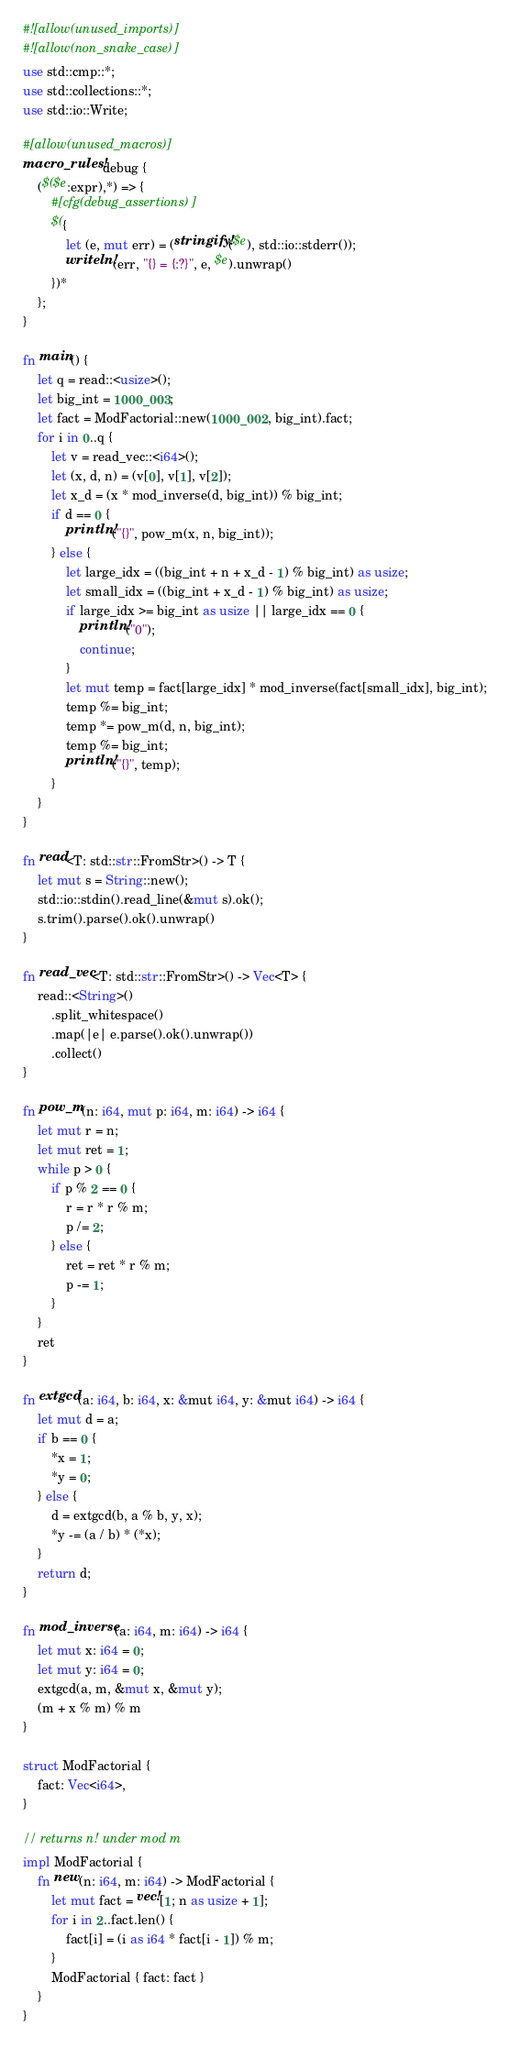<code> <loc_0><loc_0><loc_500><loc_500><_Rust_>#![allow(unused_imports)]
#![allow(non_snake_case)]
use std::cmp::*;
use std::collections::*;
use std::io::Write;

#[allow(unused_macros)]
macro_rules! debug {
    ($($e:expr),*) => {
        #[cfg(debug_assertions)]
        $({
            let (e, mut err) = (stringify!($e), std::io::stderr());
            writeln!(err, "{} = {:?}", e, $e).unwrap()
        })*
    };
}

fn main() {
    let q = read::<usize>();
    let big_int = 1000_003;
    let fact = ModFactorial::new(1000_002, big_int).fact;
    for i in 0..q {
        let v = read_vec::<i64>();
        let (x, d, n) = (v[0], v[1], v[2]);
        let x_d = (x * mod_inverse(d, big_int)) % big_int;
        if d == 0 {
            println!("{}", pow_m(x, n, big_int));
        } else {
            let large_idx = ((big_int + n + x_d - 1) % big_int) as usize;
            let small_idx = ((big_int + x_d - 1) % big_int) as usize;
            if large_idx >= big_int as usize || large_idx == 0 {
                println!("0");
                continue;
            }
            let mut temp = fact[large_idx] * mod_inverse(fact[small_idx], big_int);
            temp %= big_int;
            temp *= pow_m(d, n, big_int);
            temp %= big_int;
            println!("{}", temp);
        }
    }
}

fn read<T: std::str::FromStr>() -> T {
    let mut s = String::new();
    std::io::stdin().read_line(&mut s).ok();
    s.trim().parse().ok().unwrap()
}

fn read_vec<T: std::str::FromStr>() -> Vec<T> {
    read::<String>()
        .split_whitespace()
        .map(|e| e.parse().ok().unwrap())
        .collect()
}

fn pow_m(n: i64, mut p: i64, m: i64) -> i64 {
    let mut r = n;
    let mut ret = 1;
    while p > 0 {
        if p % 2 == 0 {
            r = r * r % m;
            p /= 2;
        } else {
            ret = ret * r % m;
            p -= 1;
        }
    }
    ret
}

fn extgcd(a: i64, b: i64, x: &mut i64, y: &mut i64) -> i64 {
    let mut d = a;
    if b == 0 {
        *x = 1;
        *y = 0;
    } else {
        d = extgcd(b, a % b, y, x);
        *y -= (a / b) * (*x);
    }
    return d;
}

fn mod_inverse(a: i64, m: i64) -> i64 {
    let mut x: i64 = 0;
    let mut y: i64 = 0;
    extgcd(a, m, &mut x, &mut y);
    (m + x % m) % m
}

struct ModFactorial {
    fact: Vec<i64>,
}

// returns n! under mod m
impl ModFactorial {
    fn new(n: i64, m: i64) -> ModFactorial {
        let mut fact = vec![1; n as usize + 1];
        for i in 2..fact.len() {
            fact[i] = (i as i64 * fact[i - 1]) % m;
        }
        ModFactorial { fact: fact }
    }
}
</code> 